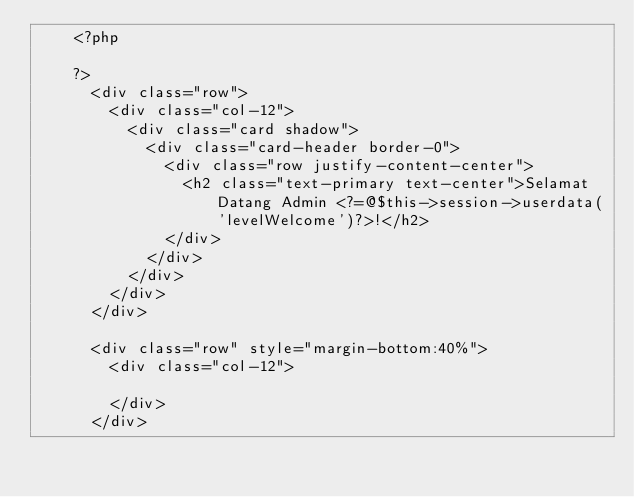<code> <loc_0><loc_0><loc_500><loc_500><_PHP_>    <?php
      
    ?>
      <div class="row">
        <div class="col-12">
          <div class="card shadow">
            <div class="card-header border-0">
              <div class="row justify-content-center">
                <h2 class="text-primary text-center">Selamat Datang Admin <?=@$this->session->userdata('levelWelcome')?>!</h2>
              </div>
            </div>
          </div>
        </div>
      </div>

      <div class="row" style="margin-bottom:40%">
        <div class="col-12">
          
        </div>
      </div></code> 